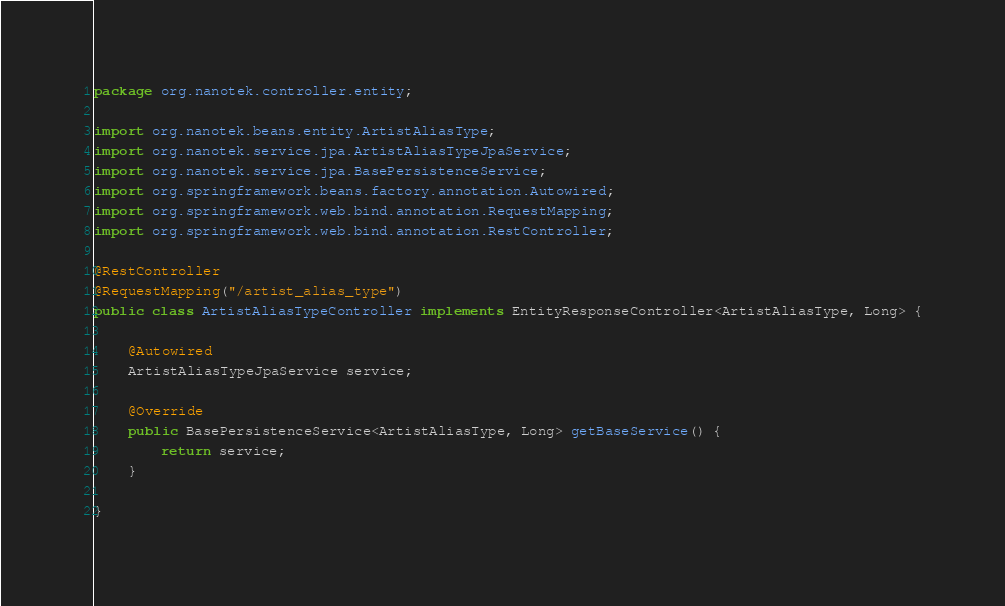<code> <loc_0><loc_0><loc_500><loc_500><_Java_>package org.nanotek.controller.entity;

import org.nanotek.beans.entity.ArtistAliasType;
import org.nanotek.service.jpa.ArtistAliasTypeJpaService;
import org.nanotek.service.jpa.BasePersistenceService;
import org.springframework.beans.factory.annotation.Autowired;
import org.springframework.web.bind.annotation.RequestMapping;
import org.springframework.web.bind.annotation.RestController;

@RestController
@RequestMapping("/artist_alias_type")
public class ArtistAliasTypeController implements EntityResponseController<ArtistAliasType, Long> {

	@Autowired
	ArtistAliasTypeJpaService service;
	
	@Override
	public BasePersistenceService<ArtistAliasType, Long> getBaseService() {
		return service;
	}

}
</code> 